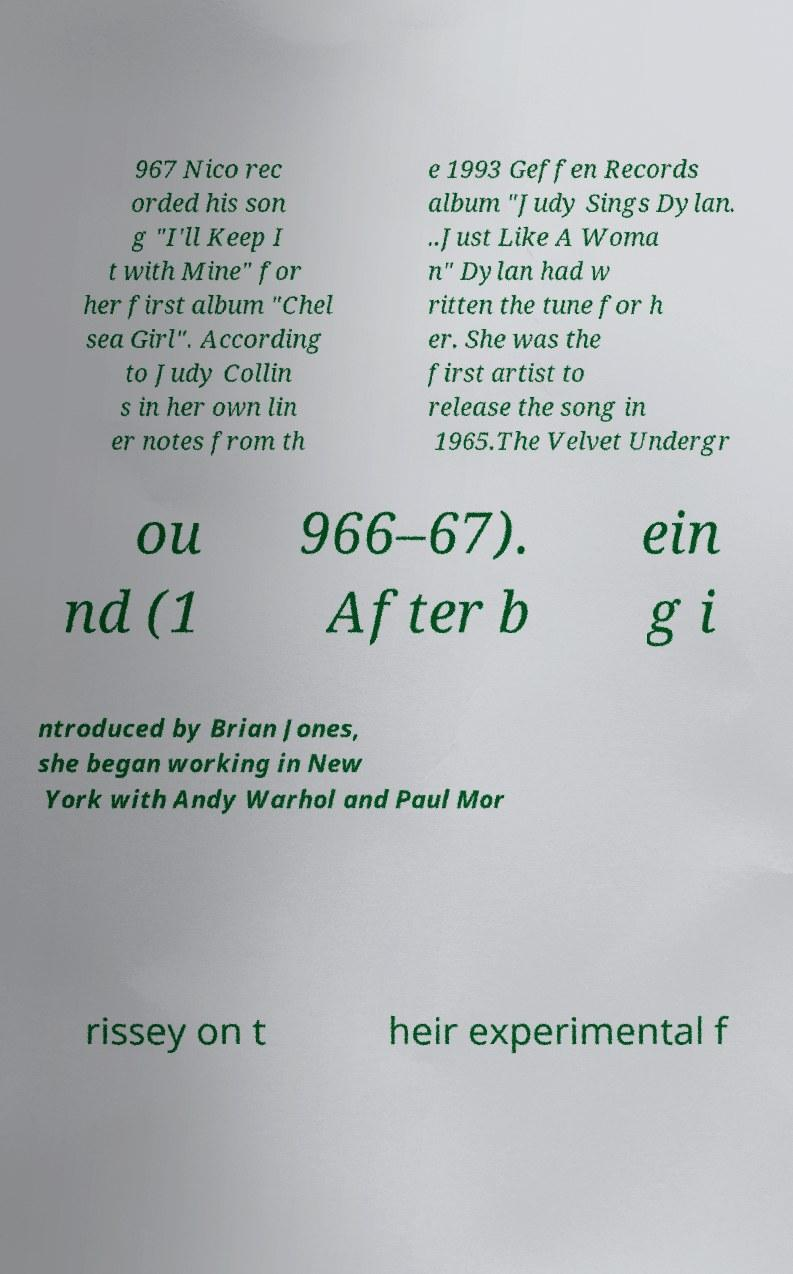Please read and relay the text visible in this image. What does it say? 967 Nico rec orded his son g "I'll Keep I t with Mine" for her first album "Chel sea Girl". According to Judy Collin s in her own lin er notes from th e 1993 Geffen Records album "Judy Sings Dylan. ..Just Like A Woma n" Dylan had w ritten the tune for h er. She was the first artist to release the song in 1965.The Velvet Undergr ou nd (1 966–67). After b ein g i ntroduced by Brian Jones, she began working in New York with Andy Warhol and Paul Mor rissey on t heir experimental f 